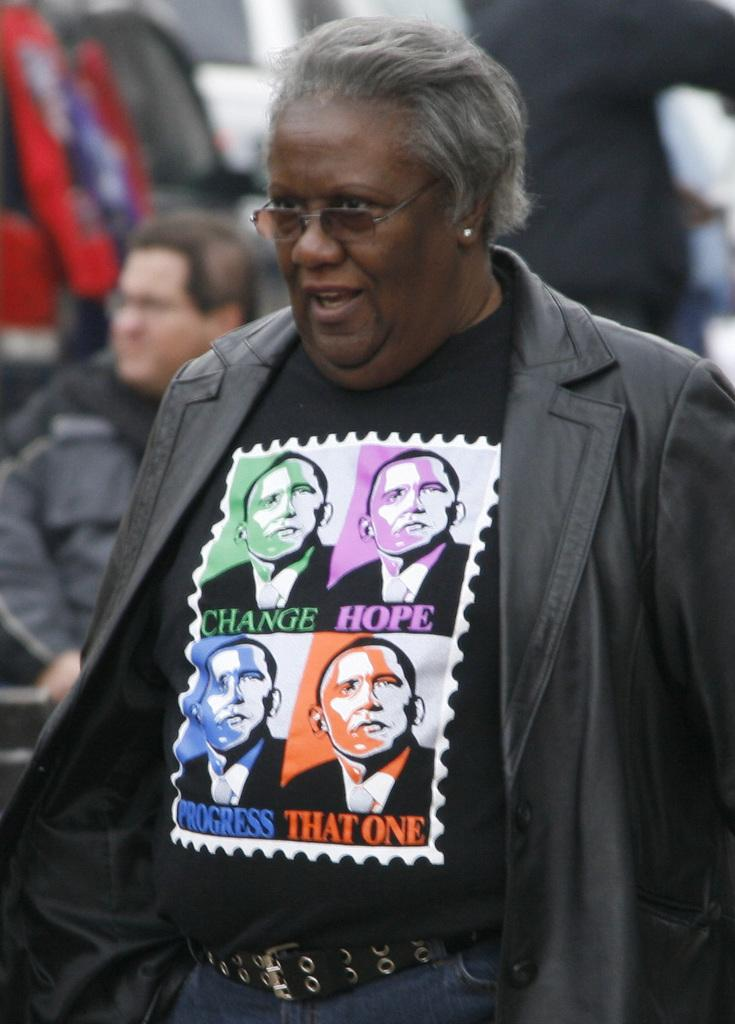What is the person in the image wearing? The person in the image is wearing a jacket. Can you describe any accessories the person is wearing? The person is wearing glasses. Are there any other people visible in the image? Yes, there is another person visible in the background of the image. What type of grape is the person holding in the image? There is no grape present in the image; the person is wearing a jacket and glasses. 